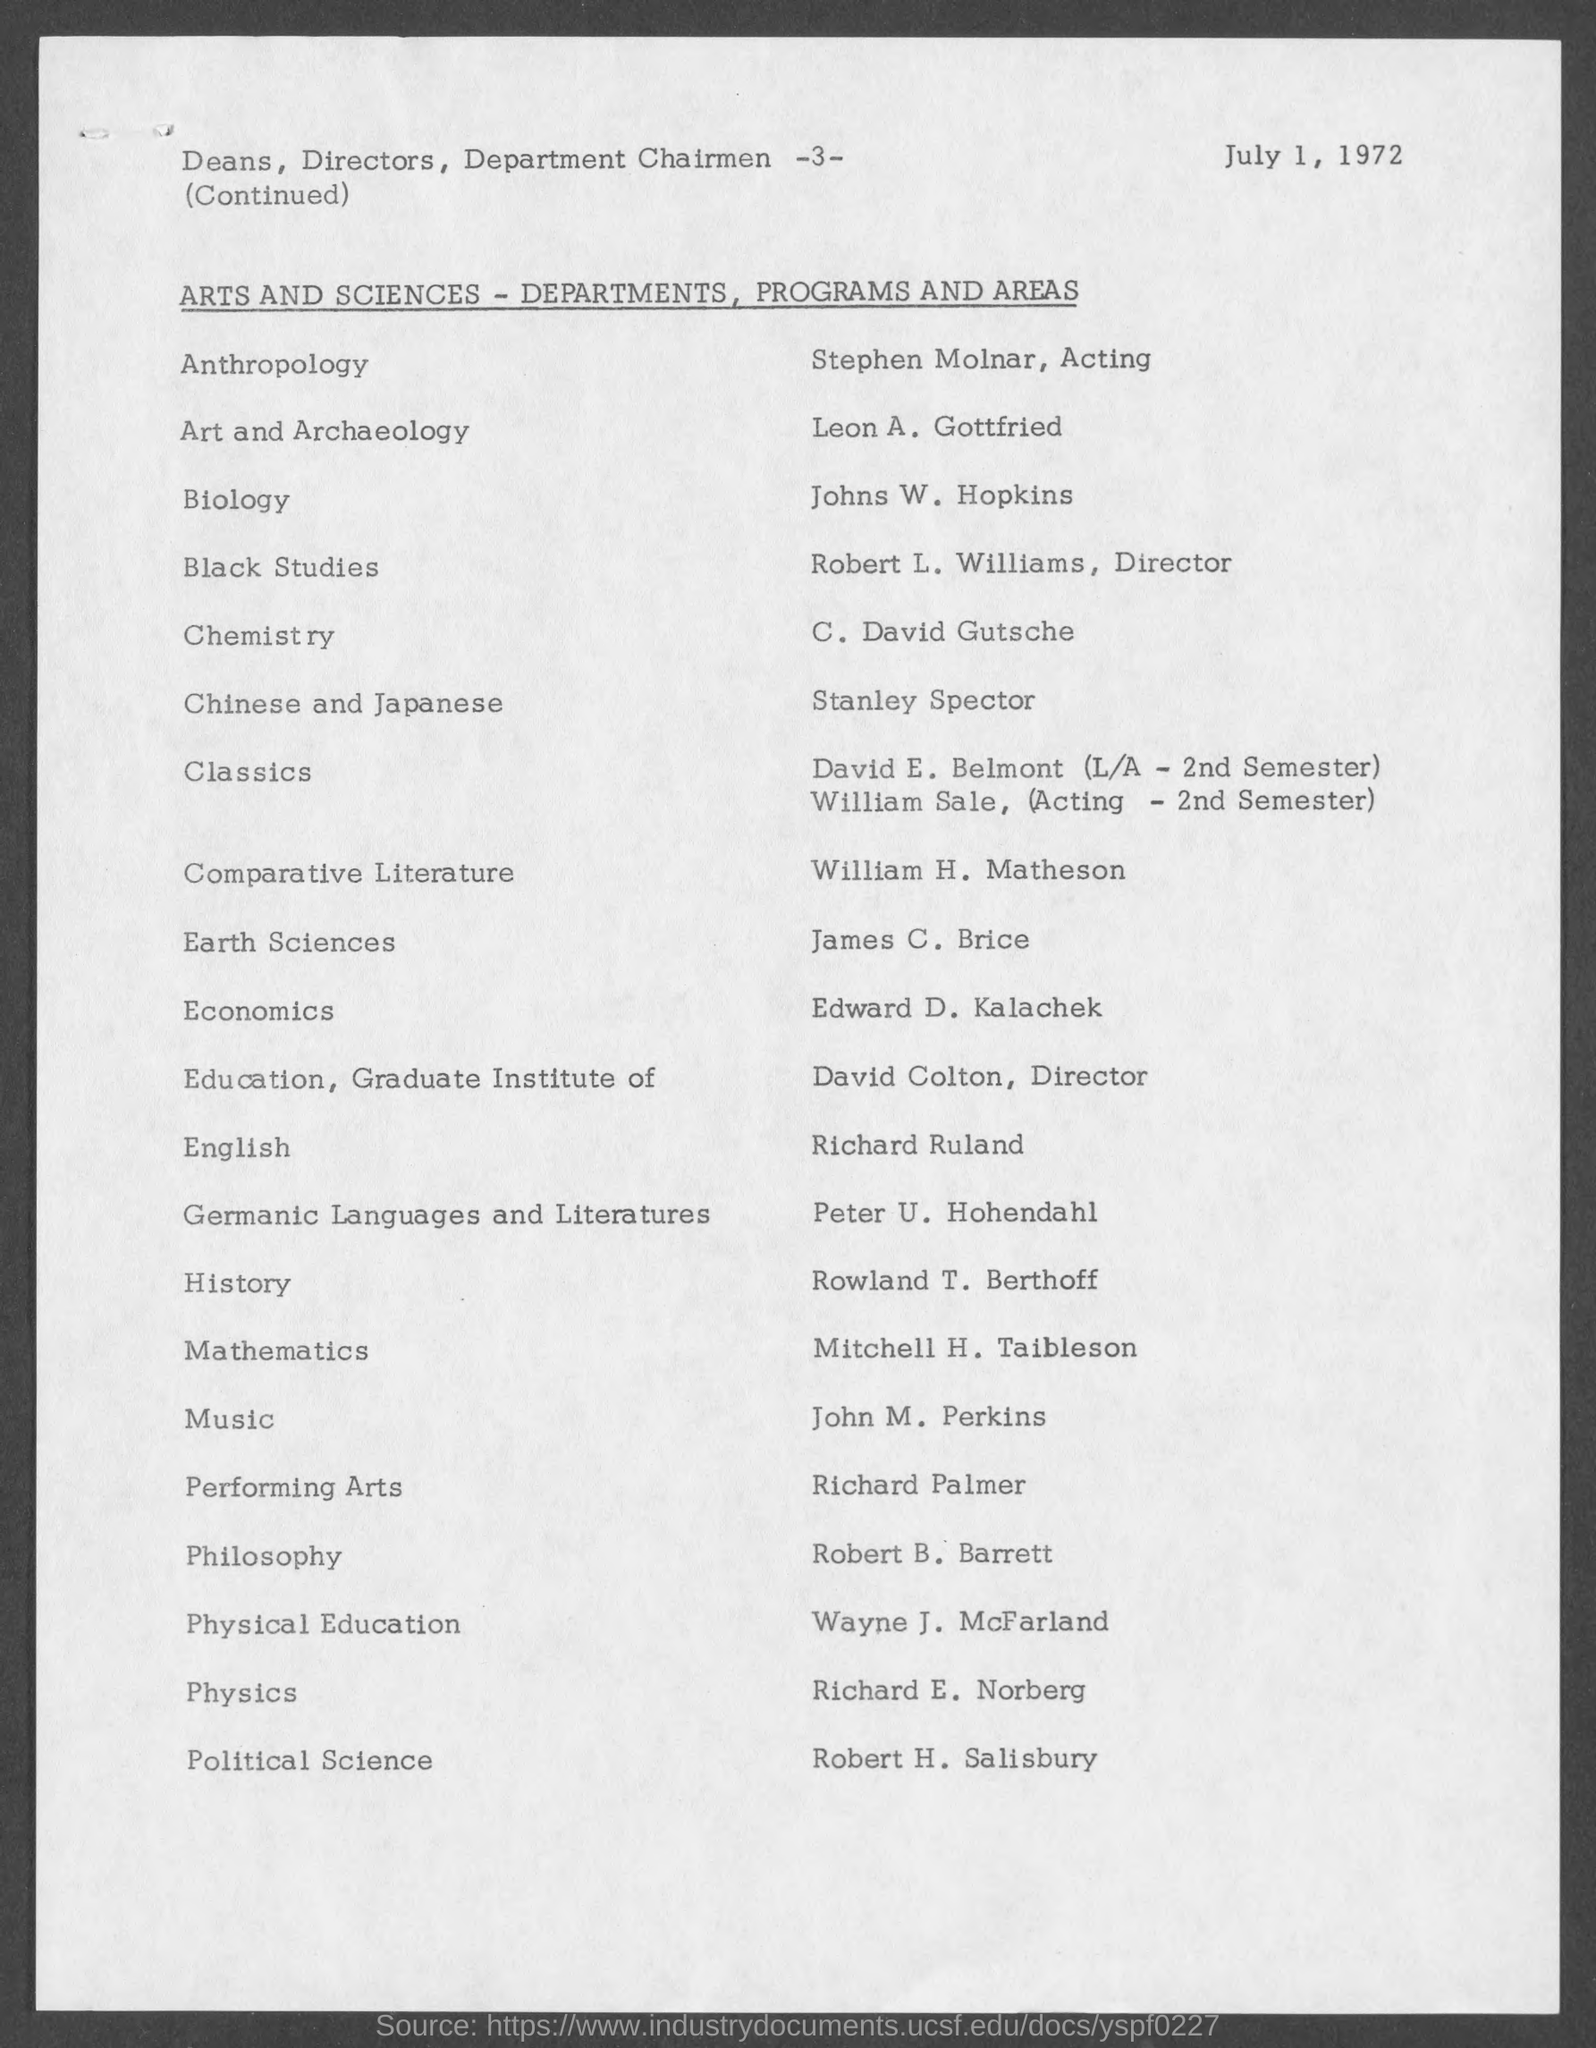Identify some key points in this picture. The page number at the top of the page is -3-. Stanley Spector belongs to the department of Chinese and Japanese. Leon A. Gottfried is a member of the Art and Archaeology department. Richard E. Norberg belongs to the department of physics. C. David Gutsche belongs to the Chemistry department. 